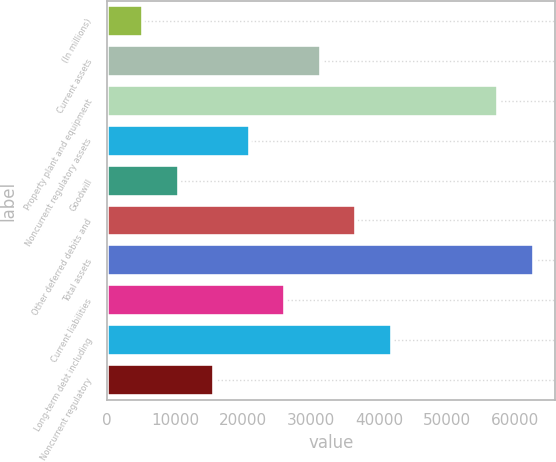Convert chart to OTSL. <chart><loc_0><loc_0><loc_500><loc_500><bar_chart><fcel>(In millions)<fcel>Current assets<fcel>Property plant and equipment<fcel>Noncurrent regulatory assets<fcel>Goodwill<fcel>Other deferred debits and<fcel>Total assets<fcel>Current liabilities<fcel>Long-term debt including<fcel>Noncurrent regulatory<nl><fcel>5302.3<fcel>31378.8<fcel>57455.3<fcel>20948.2<fcel>10517.6<fcel>36594.1<fcel>62670.6<fcel>26163.5<fcel>41809.4<fcel>15732.9<nl></chart> 